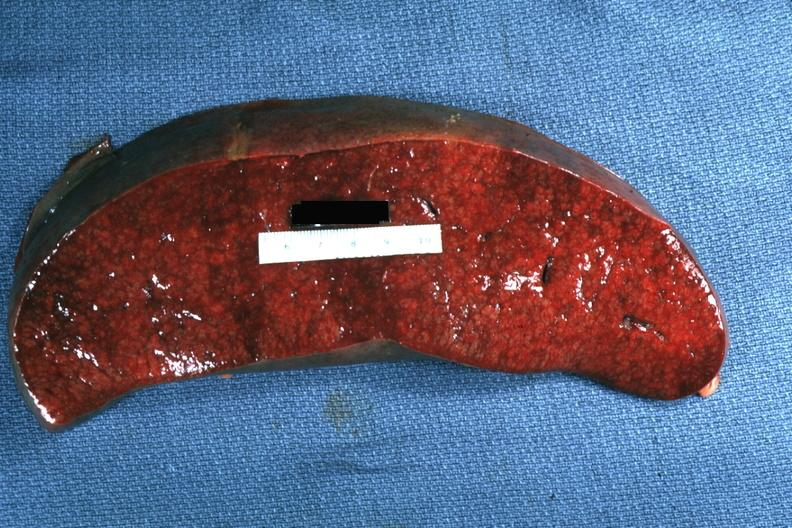what is present?
Answer the question using a single word or phrase. Spleen 